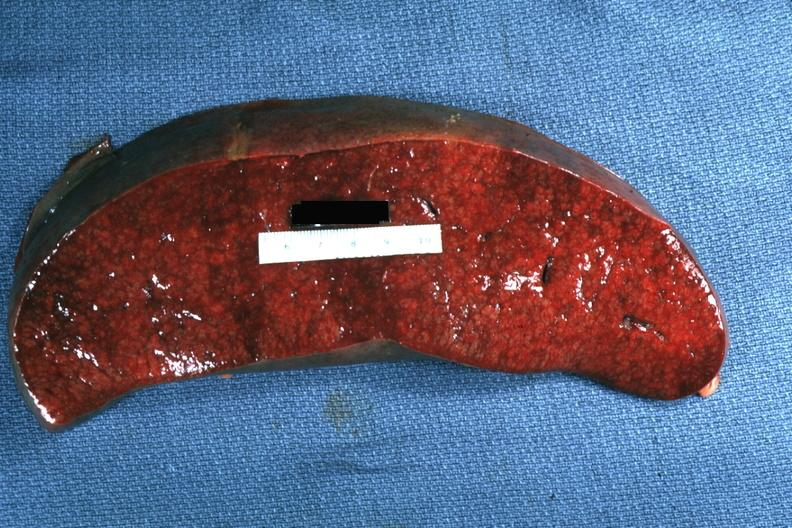what is present?
Answer the question using a single word or phrase. Spleen 